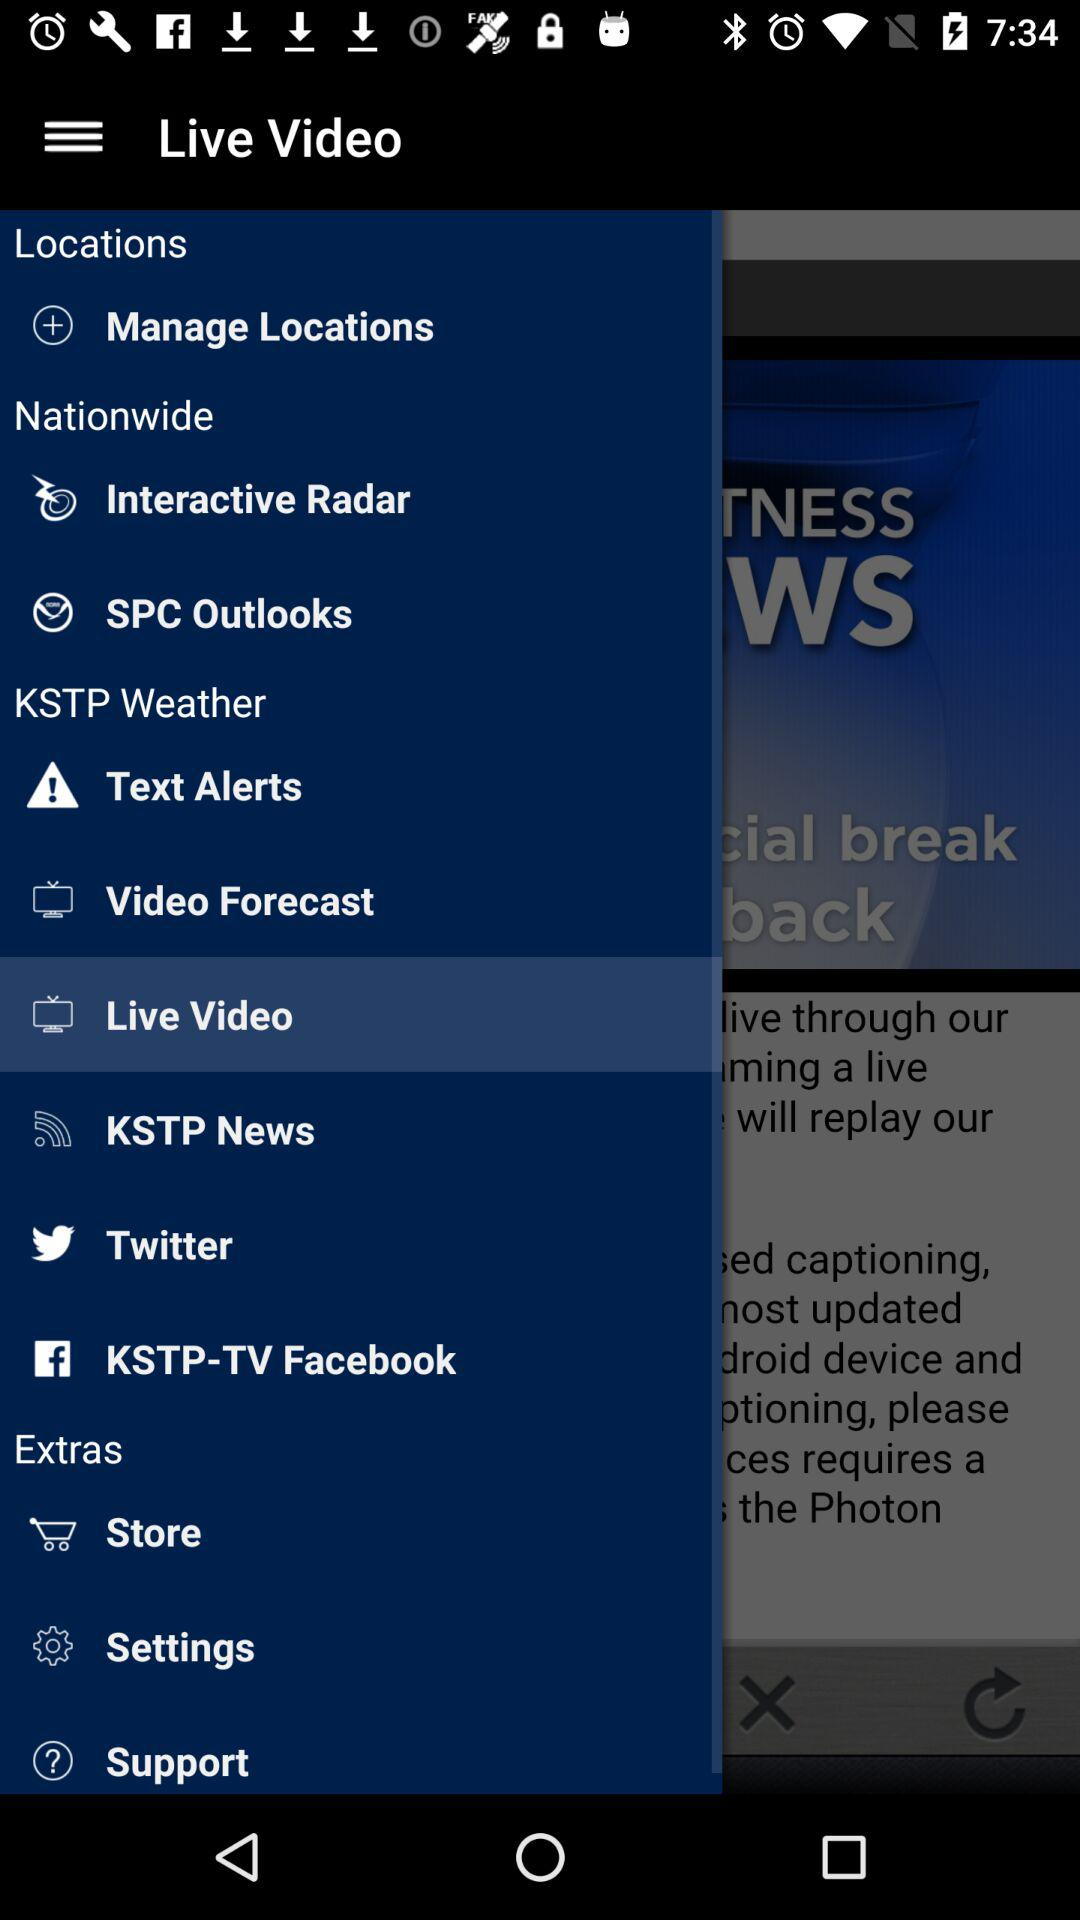Will the weather be nicer tomorrow?
When the provided information is insufficient, respond with <no answer>. <no answer> 